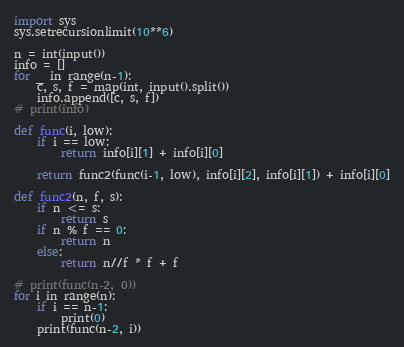Convert code to text. <code><loc_0><loc_0><loc_500><loc_500><_Python_>import sys
sys.setrecursionlimit(10**6)

n = int(input())
info = []
for _ in range(n-1):
    c, s, f = map(int, input().split())
    info.append([c, s, f])
# print(info)

def func(i, low):
    if i == low:
        return info[i][1] + info[i][0]

    return func2(func(i-1, low), info[i][2], info[i][1]) + info[i][0]

def func2(n, f, s):
    if n <= s:
        return s
    if n % f == 0:
        return n
    else:
        return n//f * f + f

# print(func(n-2, 0))
for i in range(n):
    if i == n-1:
        print(0)
    print(func(n-2, i))</code> 